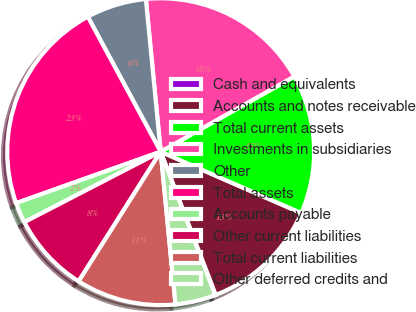<chart> <loc_0><loc_0><loc_500><loc_500><pie_chart><fcel>Cash and equivalents<fcel>Accounts and notes receivable<fcel>Total current assets<fcel>Investments in subsidiaries<fcel>Other<fcel>Total assets<fcel>Accounts payable<fcel>Other current liabilities<fcel>Total current liabilities<fcel>Other deferred credits and<nl><fcel>0.06%<fcel>12.61%<fcel>14.71%<fcel>18.38%<fcel>6.34%<fcel>22.56%<fcel>2.15%<fcel>8.43%<fcel>10.52%<fcel>4.24%<nl></chart> 